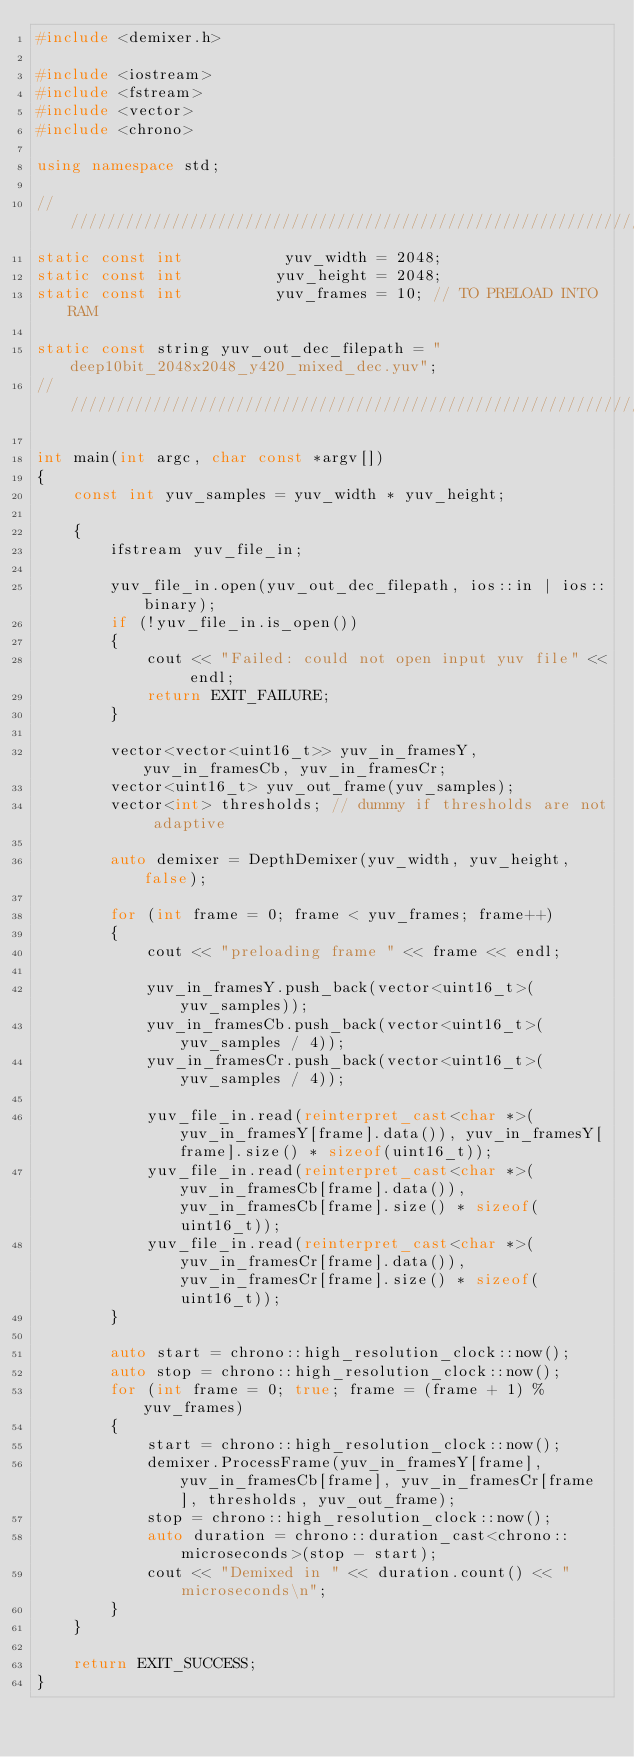Convert code to text. <code><loc_0><loc_0><loc_500><loc_500><_C++_>#include <demixer.h>

#include <iostream>
#include <fstream>
#include <vector>
#include <chrono>

using namespace std;

//////////////////////////////////////////////////////////////////////////////////////////////
static const int           yuv_width = 2048;
static const int          yuv_height = 2048;
static const int          yuv_frames = 10; // TO PRELOAD INTO RAM

static const string yuv_out_dec_filepath = "deep10bit_2048x2048_y420_mixed_dec.yuv";
//////////////////////////////////////////////////////////////////////////////////////////////

int main(int argc, char const *argv[])
{
    const int yuv_samples = yuv_width * yuv_height;

    {
        ifstream yuv_file_in;

        yuv_file_in.open(yuv_out_dec_filepath, ios::in | ios::binary);
        if (!yuv_file_in.is_open())
        {
            cout << "Failed: could not open input yuv file" << endl;
            return EXIT_FAILURE;
        }

        vector<vector<uint16_t>> yuv_in_framesY, yuv_in_framesCb, yuv_in_framesCr;
        vector<uint16_t> yuv_out_frame(yuv_samples);
        vector<int> thresholds; // dummy if thresholds are not adaptive

        auto demixer = DepthDemixer(yuv_width, yuv_height, false);

        for (int frame = 0; frame < yuv_frames; frame++)
        {
            cout << "preloading frame " << frame << endl;

            yuv_in_framesY.push_back(vector<uint16_t>(yuv_samples));
            yuv_in_framesCb.push_back(vector<uint16_t>(yuv_samples / 4));
            yuv_in_framesCr.push_back(vector<uint16_t>(yuv_samples / 4));

            yuv_file_in.read(reinterpret_cast<char *>(yuv_in_framesY[frame].data()), yuv_in_framesY[frame].size() * sizeof(uint16_t));
            yuv_file_in.read(reinterpret_cast<char *>(yuv_in_framesCb[frame].data()), yuv_in_framesCb[frame].size() * sizeof(uint16_t));
            yuv_file_in.read(reinterpret_cast<char *>(yuv_in_framesCr[frame].data()), yuv_in_framesCr[frame].size() * sizeof(uint16_t));
        }

        auto start = chrono::high_resolution_clock::now();
        auto stop = chrono::high_resolution_clock::now(); 
        for (int frame = 0; true; frame = (frame + 1) % yuv_frames)
        {
            start = chrono::high_resolution_clock::now(); 
            demixer.ProcessFrame(yuv_in_framesY[frame], yuv_in_framesCb[frame], yuv_in_framesCr[frame], thresholds, yuv_out_frame);
            stop = chrono::high_resolution_clock::now();
            auto duration = chrono::duration_cast<chrono::microseconds>(stop - start);
            cout << "Demixed in " << duration.count() << " microseconds\n";
        }
    }

    return EXIT_SUCCESS;
}</code> 